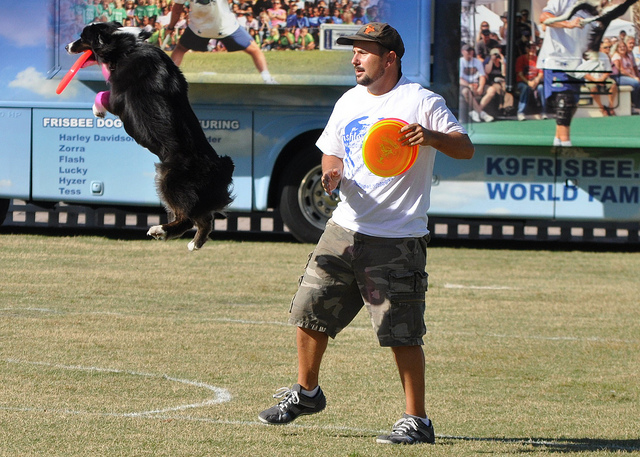Please extract the text content from this image. Zorra Finsh Lucky Hyzor Tess Davidson Harley URING DOG FRISBEE FAM WORLD K9FRISBEE. 